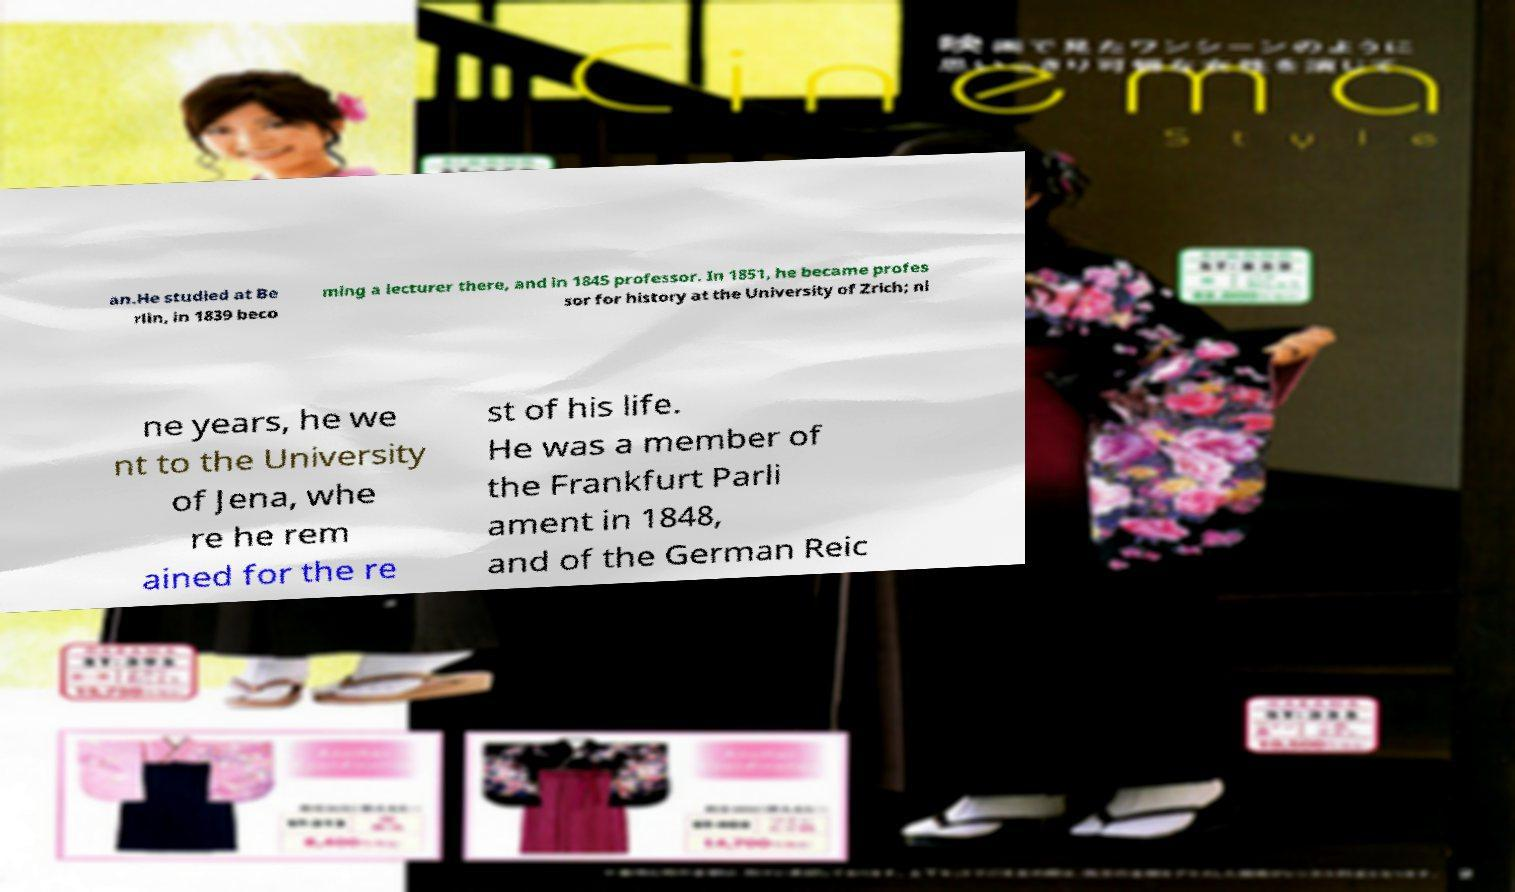Could you extract and type out the text from this image? an.He studied at Be rlin, in 1839 beco ming a lecturer there, and in 1845 professor. In 1851, he became profes sor for history at the University of Zrich; ni ne years, he we nt to the University of Jena, whe re he rem ained for the re st of his life. He was a member of the Frankfurt Parli ament in 1848, and of the German Reic 